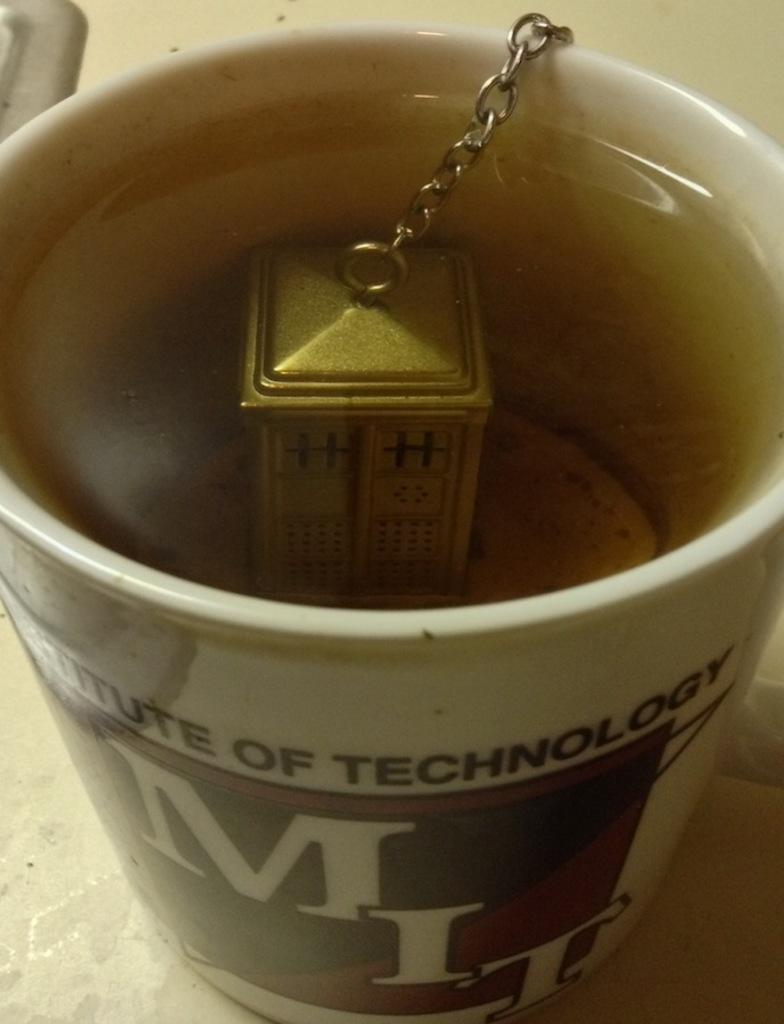<image>
Write a terse but informative summary of the picture. A mug that says MIT has a gold tea bag made of metal in it. 